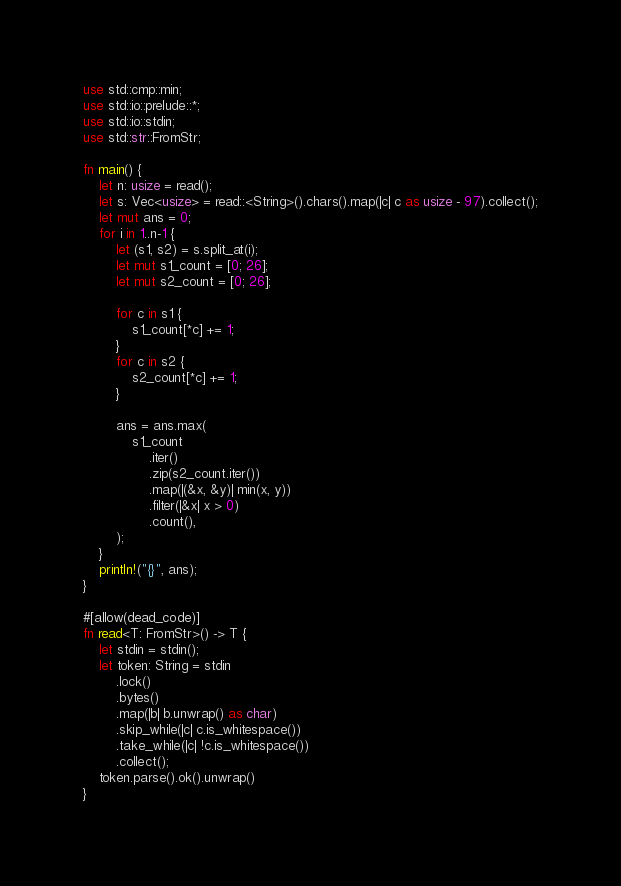<code> <loc_0><loc_0><loc_500><loc_500><_Rust_>use std::cmp::min;
use std::io::prelude::*;
use std::io::stdin;
use std::str::FromStr;

fn main() {
    let n: usize = read();
    let s: Vec<usize> = read::<String>().chars().map(|c| c as usize - 97).collect();
    let mut ans = 0;
    for i in 1..n-1 {
        let (s1, s2) = s.split_at(i);
        let mut s1_count = [0; 26];
        let mut s2_count = [0; 26];

        for c in s1 {
            s1_count[*c] += 1;
        }
        for c in s2 {
            s2_count[*c] += 1;
        }

        ans = ans.max(
            s1_count
                .iter()
                .zip(s2_count.iter())
                .map(|(&x, &y)| min(x, y))
                .filter(|&x| x > 0)
                .count(),
        );
    }
    println!("{}", ans);
}

#[allow(dead_code)]
fn read<T: FromStr>() -> T {
    let stdin = stdin();
    let token: String = stdin
        .lock()
        .bytes()
        .map(|b| b.unwrap() as char)
        .skip_while(|c| c.is_whitespace())
        .take_while(|c| !c.is_whitespace())
        .collect();
    token.parse().ok().unwrap()
}
</code> 